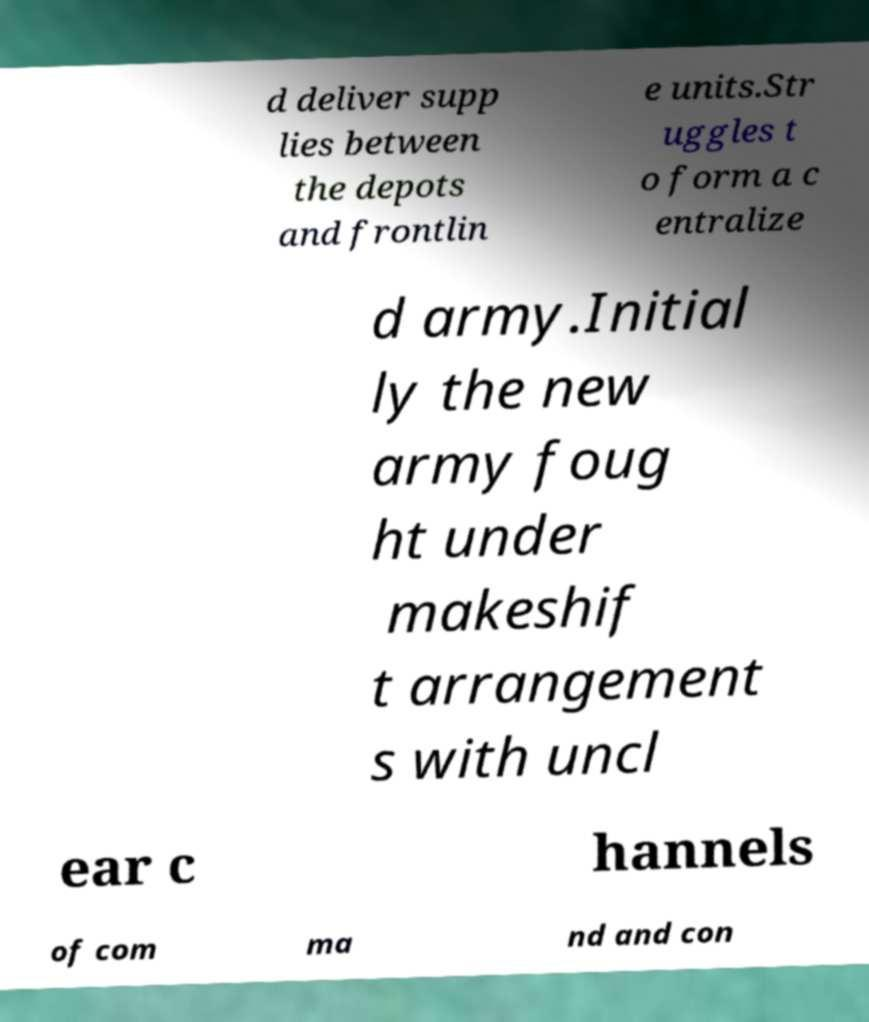I need the written content from this picture converted into text. Can you do that? d deliver supp lies between the depots and frontlin e units.Str uggles t o form a c entralize d army.Initial ly the new army foug ht under makeshif t arrangement s with uncl ear c hannels of com ma nd and con 